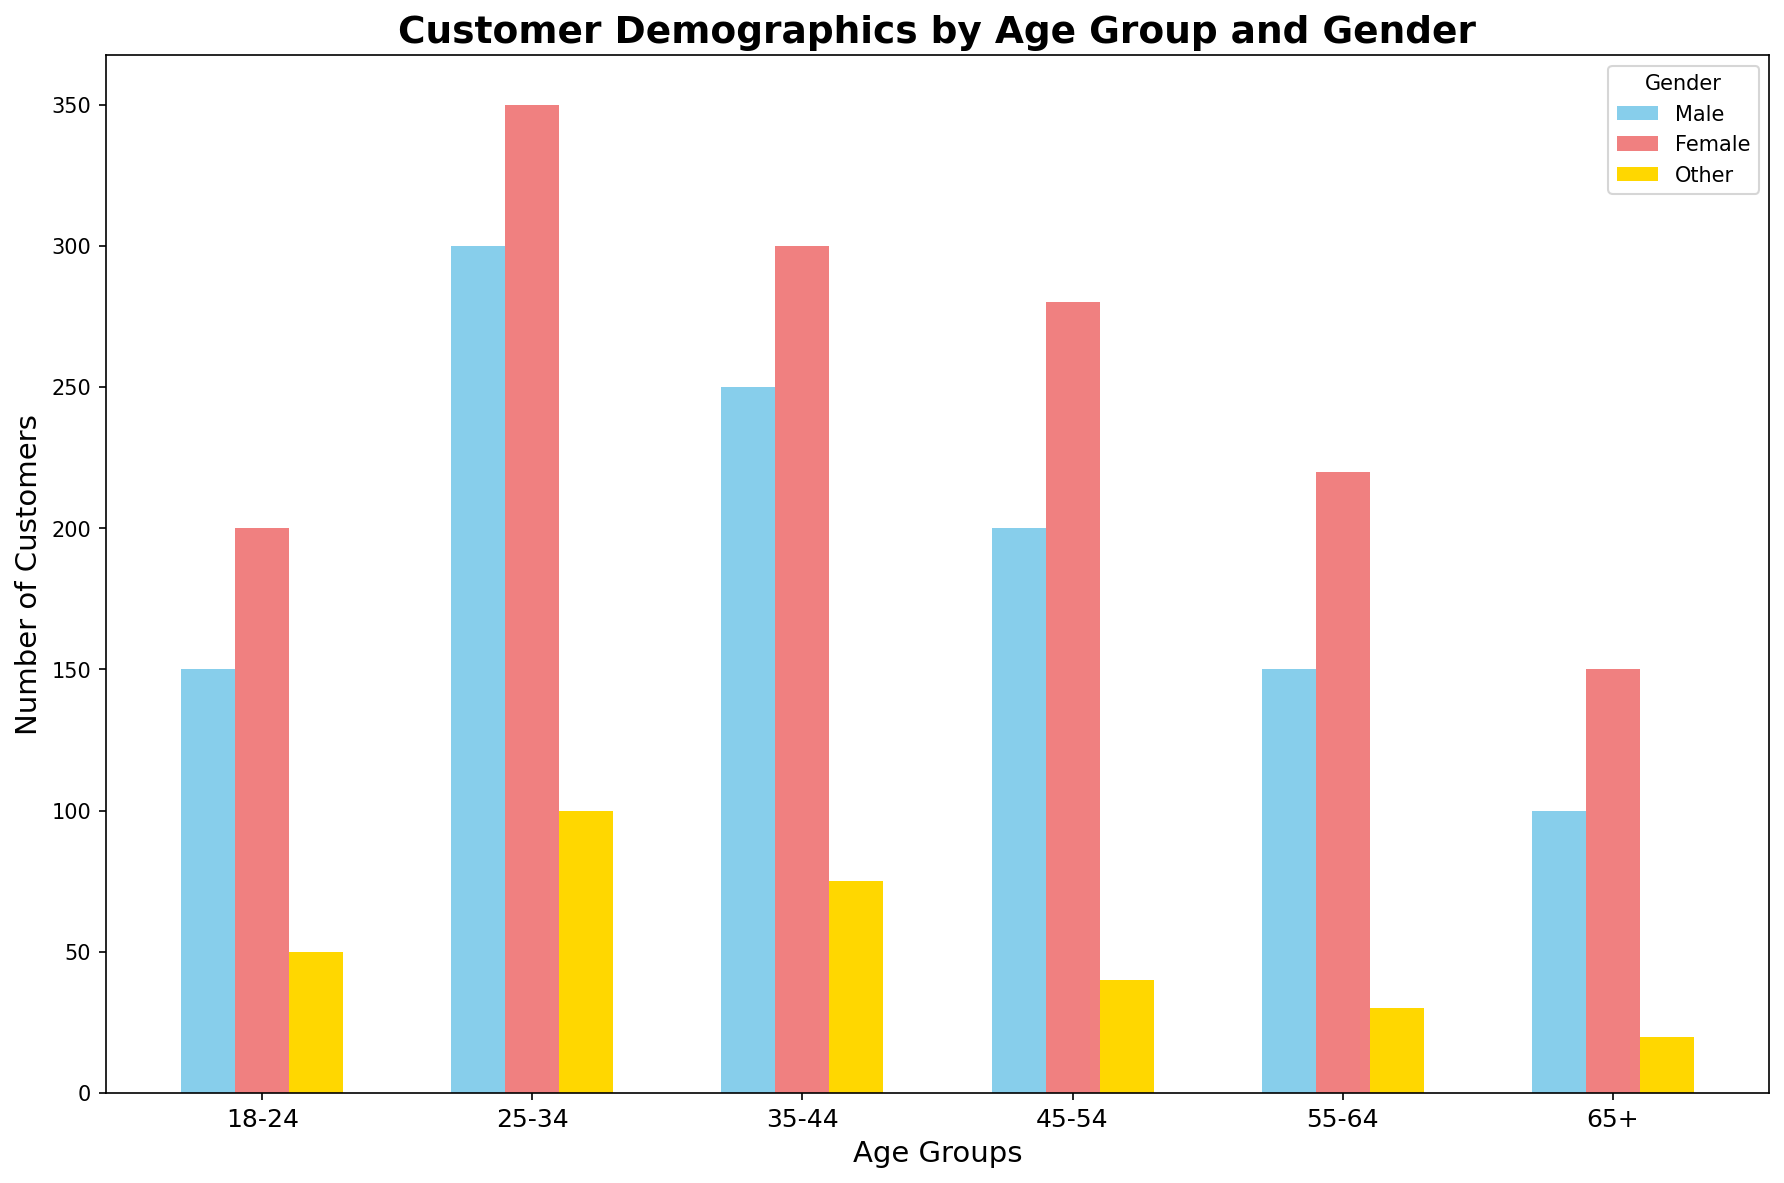What is the total number of customers in the 25-34 age group? To find the total number of customers in the 25-34 age group, sum the counts for each gender: 300 (Male) + 350 (Female) + 100 (Other) = 750.
Answer: 750 Which gender has the highest number of customers in the 35-44 age group? Look at the bars for each gender under the 35-44 age group. The Female bar is the tallest with 300 customers.
Answer: Female How does the number of Male customers in the 18-24 age group compare to the number of Female customers in the same age group? Compare the heights of the bars for Male and Female in the 18-24 age group. The Female bar (200) is taller than the Male bar (150).
Answer: Female What is the difference in the number of customers between the 45-54 and 65+ age groups for the 'Other' gender? Subtract the count for the 'Other' gender in the 65+ age group (20) from the count in the 45-54 age group (40). 40 - 20 = 20.
Answer: 20 Which age group has the least number of 'Other' gender customers? Compare the heights of the yellow bars (Other) across all age groups. The 65+ age group has the shortest bar with 20 customers.
Answer: 65+ Which gender-color combination represents Male customers visually? Find the color representing Male customers by looking at the legend. Male is represented by skyblue.
Answer: skyblue What is the average number of customers in the 35-44 age group? To find the average, sum the counts for Male, Female, and Other in 35-44: 250 + 300 + 75 = 625. Then, divide by 3 (genders): 625 / 3 ≈ 208.33.
Answer: 208.33 Which age group has the largest number of Female customers? Look at the bars for Female in each age group and identify the tallest one. The 25-34 age group has the tallest Female bar with 350 customers.
Answer: 25-34 What is the combined total of Male and Female customers in the 55-64 age group? Sum the counts for Male and Female in the 55-64 age group: 150 (Male) + 220 (Female) = 370.
Answer: 370 What is the most visually striking feature of the plotted demographics by age group and gender? The most visually striking feature is the significant number of Female customers in the 25-34 age group, represented by a notably tall light coral bar.
Answer: Female customers in 25-34 age group 